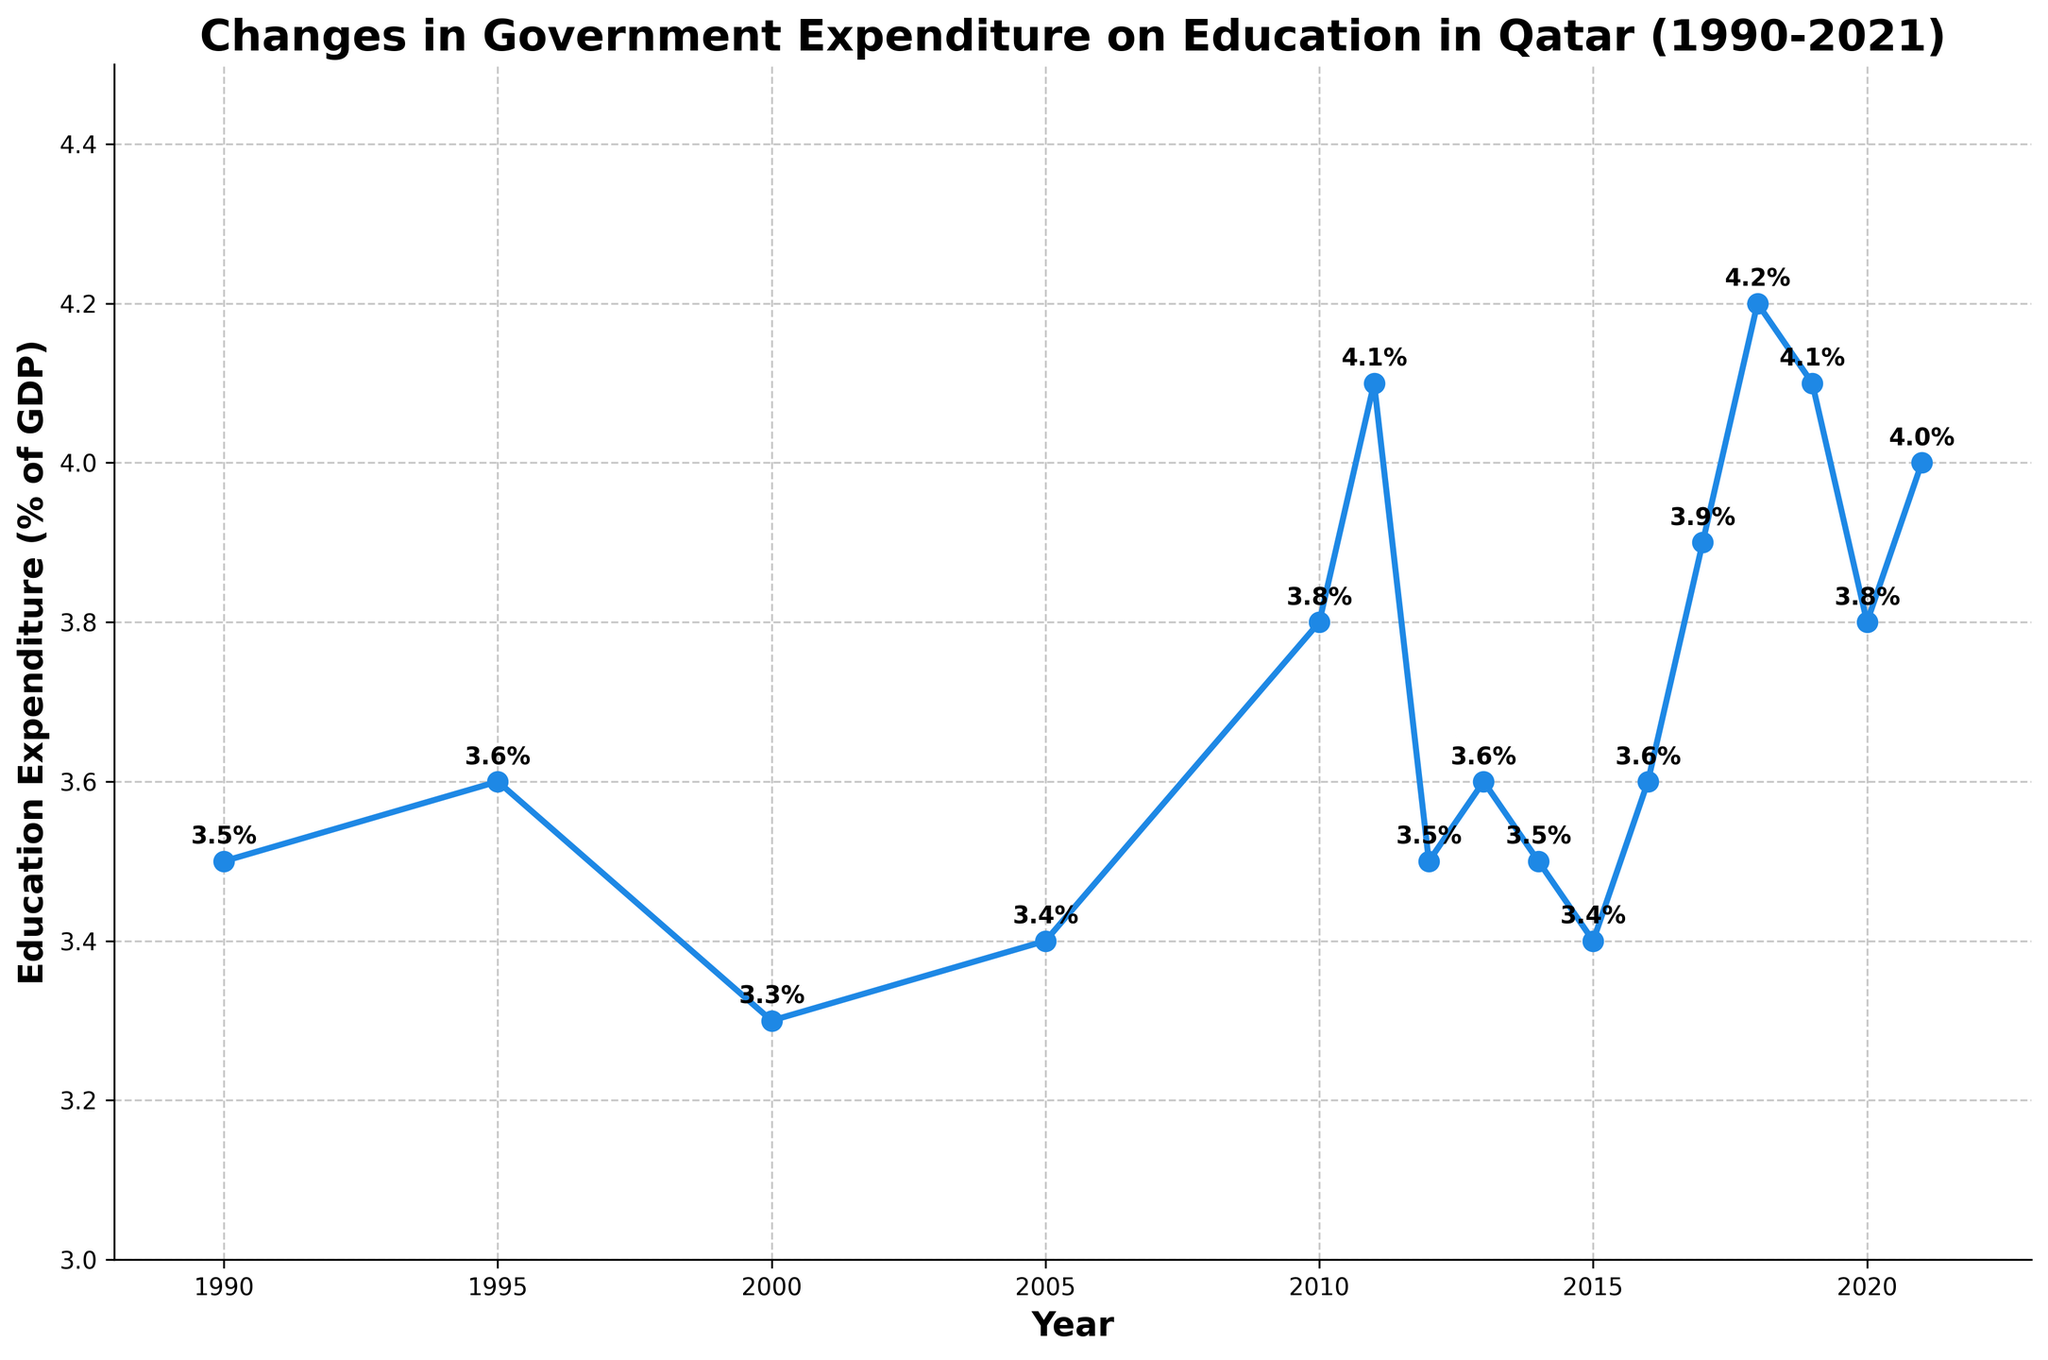What is the trend in government expenditure on education from 1990 to 2000? The expenditure decreased from 3.5% in 1990 to 3.3% in 2000, despite a small increase in 1995 to 3.6%.
Answer: Decreasing In which year was the highest government expenditure on education recorded? By examining the data, the highest expenditure was recorded in 2018 at 4.2% of GDP.
Answer: 2018 How did government expenditure on education change from 2010 to 2011? The expenditure increased from 3.8% in 2010 to 4.1% in 2011. This is calculated by subtracting the 2010 value from the 2011 value (4.1% - 3.8% = 0.3%).
Answer: Increased by 0.3% What was the average government expenditure on education during the decade from 2010 to 2020? First, sum up the expenditures from 2010 to 2020 (3.8 + 4.1 + 3.5 + 3.6 + 3.5 + 3.4 + 3.6 + 3.9 + 4.2 + 4.1 + 3.8), which equals 41.5. To find the average, divide this sum by the number of data points (41.5 / 11) = 3.77.
Answer: 3.77% Which period saw a steady increase in government expenditure on education? From 2016 to 2018, there was a steady increase each year: 3.6% (2016), 3.9% (2017), and 4.2% (2018).
Answer: 2016 to 2018 What is the difference in government expenditure on education between the years 2000 and 2021? To find the difference, subtract the expenditure in 2000 (3.3%) from that in 2021 (4.0%) (4.0% - 3.3% = 0.7%).
Answer: 0.7% How did the government expenditure on education change between 2018 and 2020? The expenditure initially decreased from 4.2% in 2018 to 4.1% in 2019, and then to 3.8% in 2020.
Answer: Decreased Compare government expenditure on education in 1990 and 2021. Which year had a higher expenditure? In 2021, the expenditure was 4.0%, whereas in 1990 it was 3.5%. Hence, 2021 had a higher expenditure than 1990.
Answer: 2021 